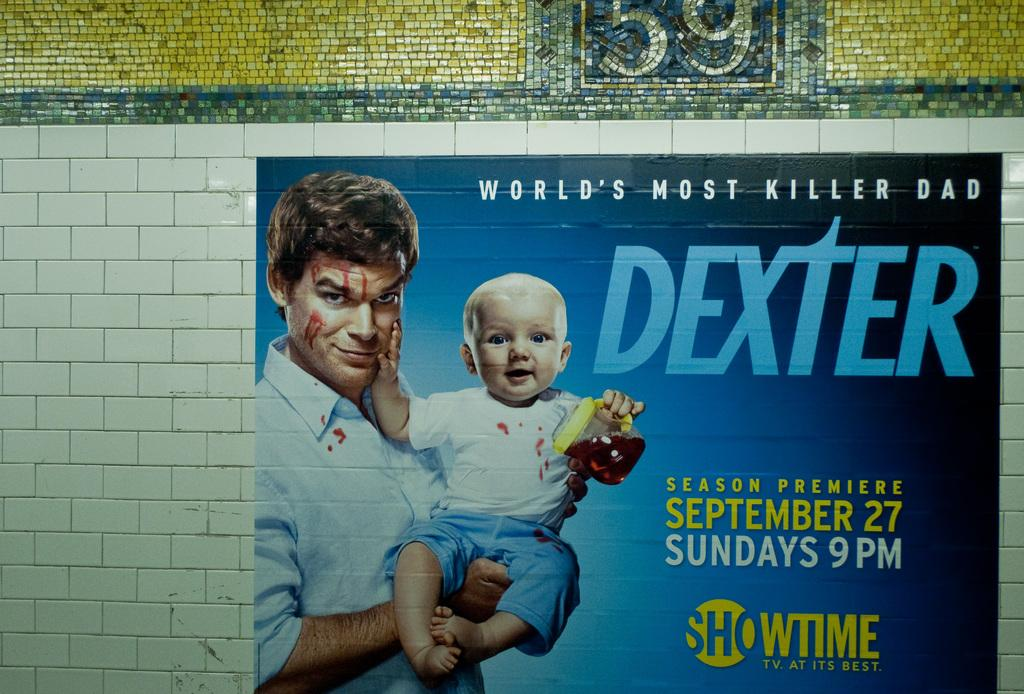What is on the wall in the image? There is a painting on the wall in the image. What is the subject matter of the painting? The painting depicts a man and a kid. What type of brake can be seen in the painting? There is no brake present in the painting; it depicts a man and a kid. How many houses are visible in the painting? There are no houses depicted in the painting; it focuses on the man and the kid. 